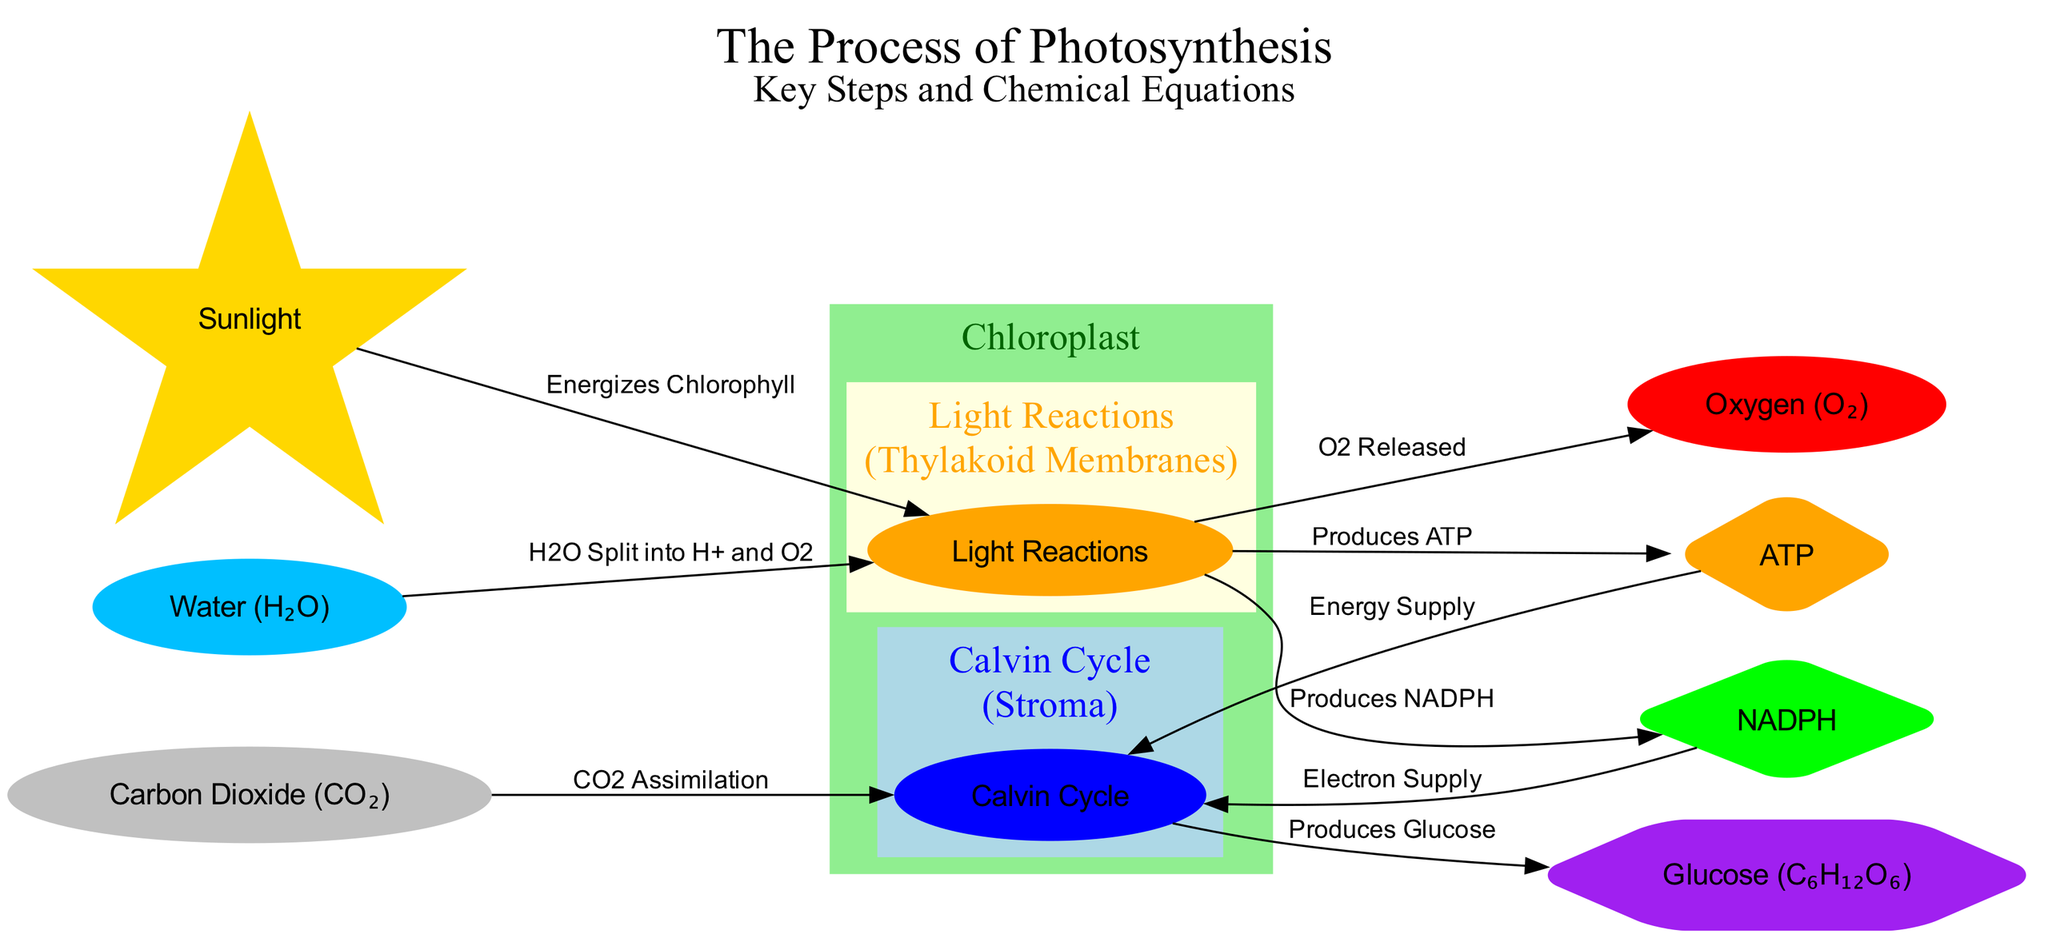What is the primary site of photosynthesis? The diagram indicates that photosynthesis occurs in the chloroplast, which is labeled as the site of photosynthesis.
Answer: Chloroplast How many chemical equations are shown in the diagram? The diagram outlines the relationships and processes, but does not specify distinct chemical equations. Nevertheless, there are one overall reaction outlined in the context of ATP and NADPH production, which can involve various equations.
Answer: 1 Which molecule is released as a byproduct of the light reactions? The diagram shows an arrow leading from the light reactions to the oxygen, indicating that oxygen is released as a byproduct.
Answer: Oxygen What role does sunlight play in this process? Sunlight energizes chlorophyll, which is indicated by the edge connecting the sunlight node to the light reactions.
Answer: Energizes Chlorophyll In which part of the chloroplast does the Calvin cycle occur? The diagram categorizes the Calvin cycle as occurring in the stroma, which is noted distinctly in the visual representation.
Answer: Stroma What are the two products generated by the light reactions? The light reactions produce both ATP and NADPH, which are connected to the light reactions in the diagram.
Answer: ATP, NADPH What type of molecule is glucose in the context of the diagram? Glucose is described as the energy storage molecule in terms of its role in the photosynthesis process, as shown in the diagram.
Answer: Energy Storage Molecule Which molecules supply energy and electrons to the Calvin cycle? ATP provides the energy supply and NADPH provides the electron supply as indicated by the connections from these molecules to the Calvin cycle node.
Answer: ATP, NADPH What process occurs when carbon dioxide is assimilated? The diagram denotes that during the Calvin cycle, carbon dioxide undergoes assimilation leading to the production of glucose, showing how these elements interact.
Answer: Produces Glucose 